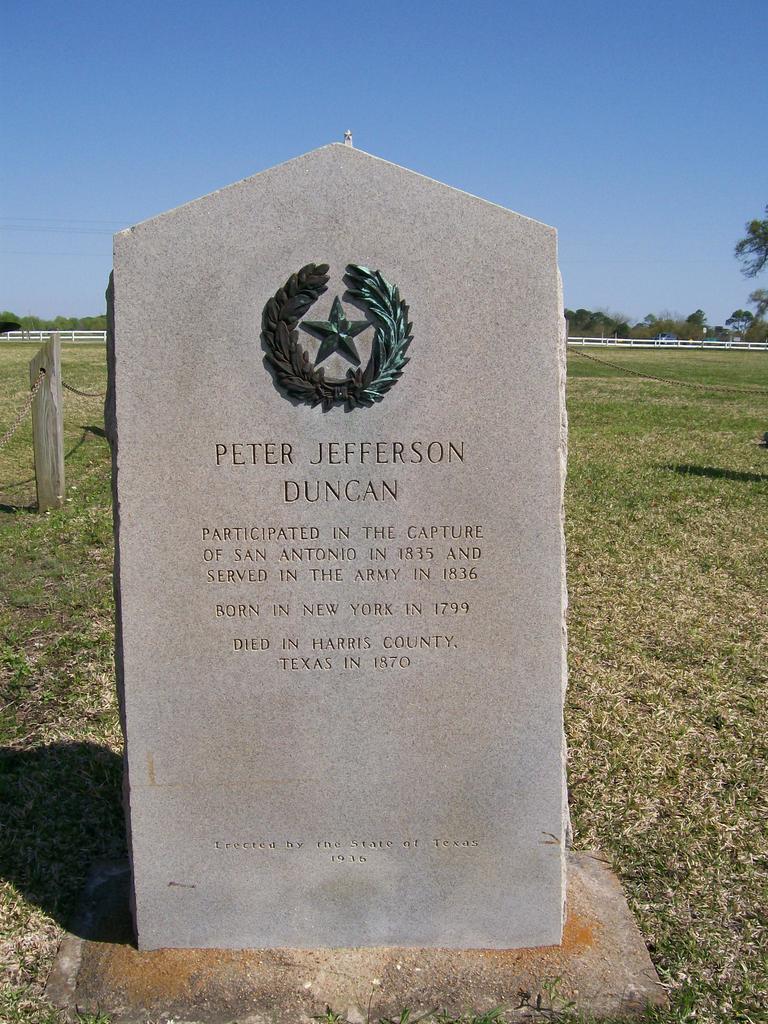Can you describe this image briefly? In this picture I can see there is a gravestone and on the floor I can see there is grass and in the backdrop I can see there is a fence, there are trees and the sky is clear. 